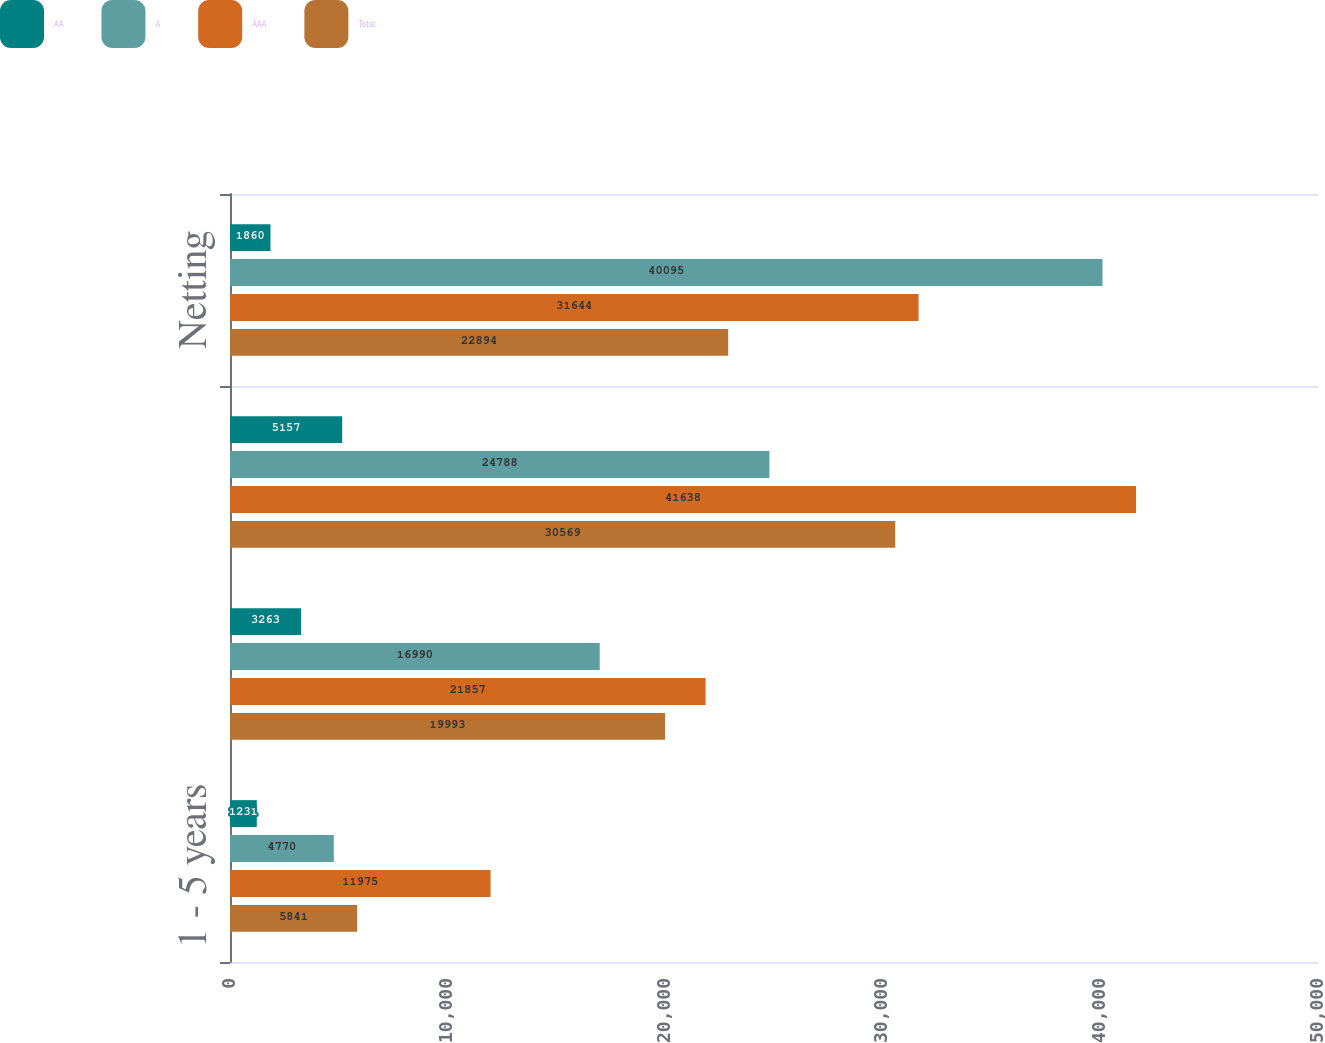Convert chart to OTSL. <chart><loc_0><loc_0><loc_500><loc_500><stacked_bar_chart><ecel><fcel>1 - 5 years<fcel>Greater than 5 years<fcel>Total<fcel>Netting<nl><fcel>AA<fcel>1231<fcel>3263<fcel>5157<fcel>1860<nl><fcel>A<fcel>4770<fcel>16990<fcel>24788<fcel>40095<nl><fcel>AAA<fcel>11975<fcel>21857<fcel>41638<fcel>31644<nl><fcel>Total<fcel>5841<fcel>19993<fcel>30569<fcel>22894<nl></chart> 